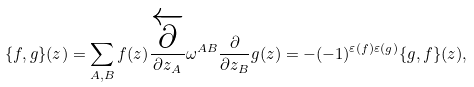<formula> <loc_0><loc_0><loc_500><loc_500>\{ f , g \} ( z ) = \sum _ { A , B } f ( z ) \frac { \overleftarrow { \partial } } { \partial z _ { A } } \omega ^ { A B } \frac { \partial } { \partial z _ { B } } g ( z ) = - ( - 1 ) ^ { \varepsilon ( f ) \varepsilon ( g ) } \{ g , f \} ( z ) ,</formula> 